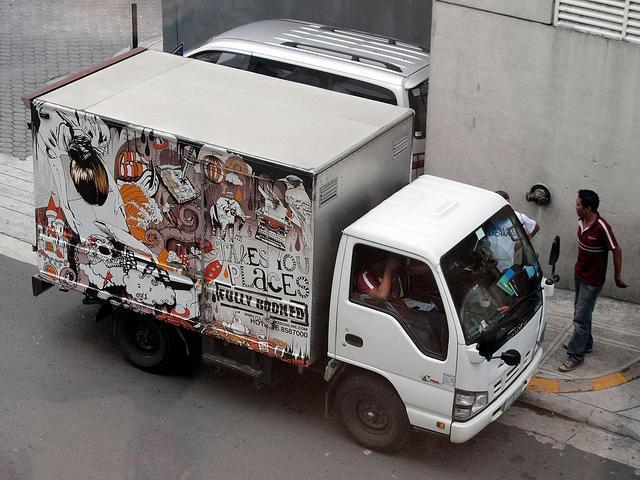Is the given caption "The elephant is part of the truck." fitting for the image?
Answer yes or no. Yes. Is the statement "The truck is ahead of the elephant." accurate regarding the image?
Answer yes or no. No. Is "The truck is behind the elephant." an appropriate description for the image?
Answer yes or no. No. Evaluate: Does the caption "The elephant is enclosed by the truck." match the image?
Answer yes or no. No. 